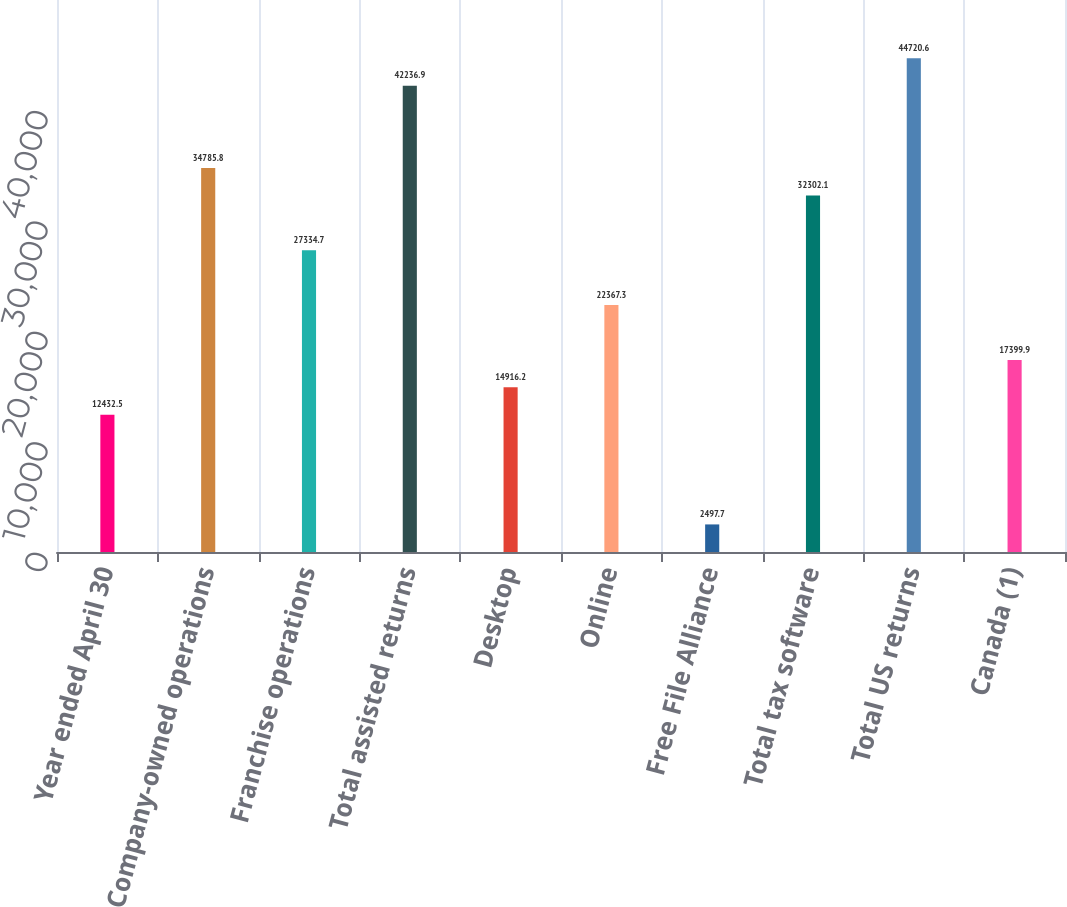Convert chart. <chart><loc_0><loc_0><loc_500><loc_500><bar_chart><fcel>Year ended April 30<fcel>Company-owned operations<fcel>Franchise operations<fcel>Total assisted returns<fcel>Desktop<fcel>Online<fcel>Free File Alliance<fcel>Total tax software<fcel>Total US returns<fcel>Canada (1)<nl><fcel>12432.5<fcel>34785.8<fcel>27334.7<fcel>42236.9<fcel>14916.2<fcel>22367.3<fcel>2497.7<fcel>32302.1<fcel>44720.6<fcel>17399.9<nl></chart> 